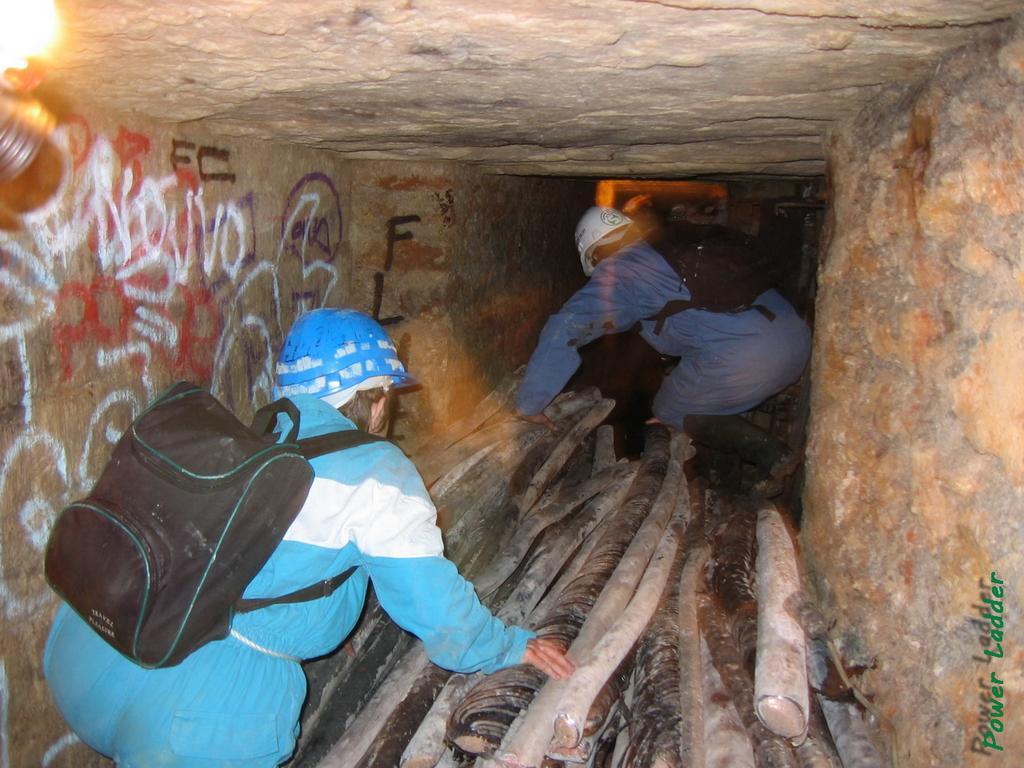Can you describe this image briefly? In this image we can see there are two persons working in a tunnel and there are some wooden sticks. 